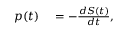Convert formula to latex. <formula><loc_0><loc_0><loc_500><loc_500>\begin{array} { r l } { p ( t ) } & = - \frac { d S ( t ) } { d t } , } \end{array}</formula> 